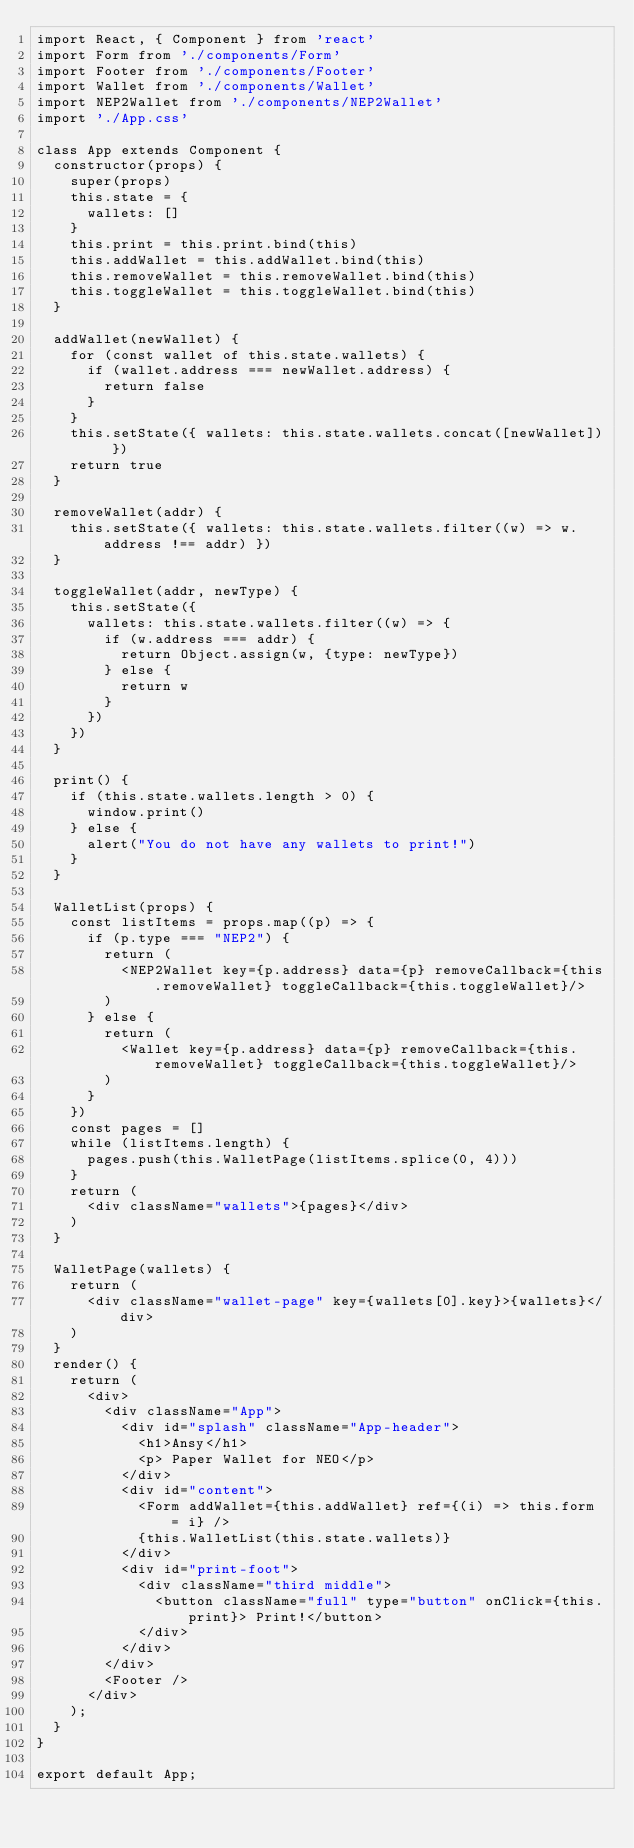<code> <loc_0><loc_0><loc_500><loc_500><_JavaScript_>import React, { Component } from 'react'
import Form from './components/Form'
import Footer from './components/Footer'
import Wallet from './components/Wallet'
import NEP2Wallet from './components/NEP2Wallet'
import './App.css'

class App extends Component {
  constructor(props) {
    super(props)
    this.state = {
      wallets: []
    }
    this.print = this.print.bind(this)
    this.addWallet = this.addWallet.bind(this)
    this.removeWallet = this.removeWallet.bind(this)
    this.toggleWallet = this.toggleWallet.bind(this)
  }

  addWallet(newWallet) {
    for (const wallet of this.state.wallets) {
      if (wallet.address === newWallet.address) {
        return false
      }
    }
    this.setState({ wallets: this.state.wallets.concat([newWallet]) })
    return true
  }

  removeWallet(addr) {
    this.setState({ wallets: this.state.wallets.filter((w) => w.address !== addr) })
  }

  toggleWallet(addr, newType) {
    this.setState({
      wallets: this.state.wallets.filter((w) => {
        if (w.address === addr) {
          return Object.assign(w, {type: newType})
        } else {
          return w
        }
      })
    })
  }

  print() {
    if (this.state.wallets.length > 0) {
      window.print()
    } else {
      alert("You do not have any wallets to print!")
    }
  }

  WalletList(props) {
    const listItems = props.map((p) => {
      if (p.type === "NEP2") {
        return (
          <NEP2Wallet key={p.address} data={p} removeCallback={this.removeWallet} toggleCallback={this.toggleWallet}/>
        )
      } else {
        return (
          <Wallet key={p.address} data={p} removeCallback={this.removeWallet} toggleCallback={this.toggleWallet}/>
        )
      }
    })
    const pages = []
    while (listItems.length) {
      pages.push(this.WalletPage(listItems.splice(0, 4)))
    }
    return (
      <div className="wallets">{pages}</div>
    )
  }

  WalletPage(wallets) {
    return (
      <div className="wallet-page" key={wallets[0].key}>{wallets}</div>
    )
  }
  render() {
    return (
      <div>
        <div className="App">
          <div id="splash" className="App-header">
            <h1>Ansy</h1>
            <p> Paper Wallet for NEO</p>
          </div>
          <div id="content">
            <Form addWallet={this.addWallet} ref={(i) => this.form = i} />
            {this.WalletList(this.state.wallets)}
          </div>
          <div id="print-foot">
            <div className="third middle">
              <button className="full" type="button" onClick={this.print}> Print!</button>
            </div>
          </div>
        </div>
        <Footer />
      </div>
    );
  }
}

export default App;
</code> 